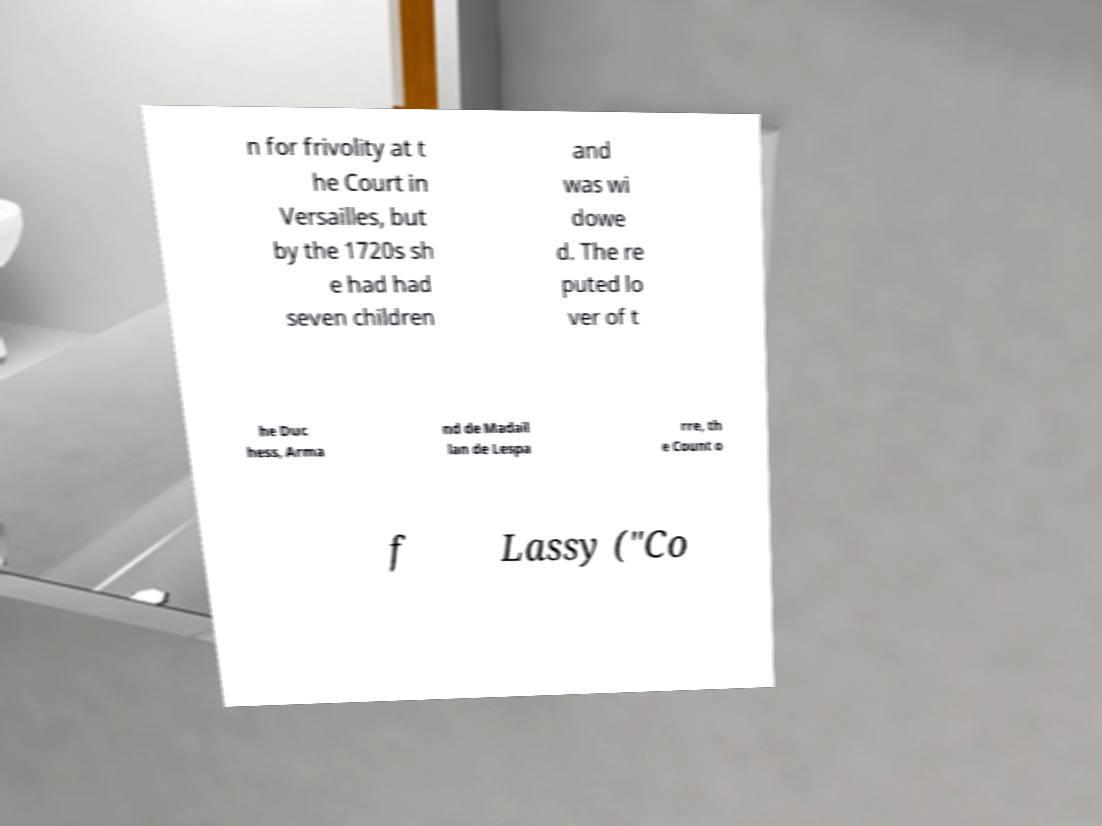I need the written content from this picture converted into text. Can you do that? n for frivolity at t he Court in Versailles, but by the 1720s sh e had had seven children and was wi dowe d. The re puted lo ver of t he Duc hess, Arma nd de Madail lan de Lespa rre, th e Count o f Lassy ("Co 